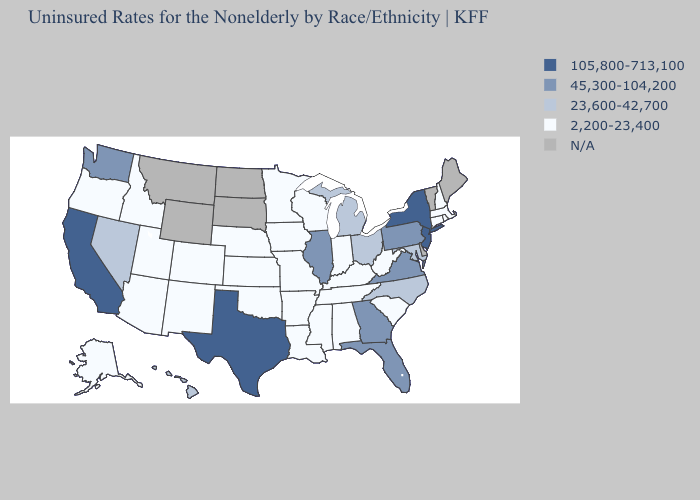What is the value of Wyoming?
Give a very brief answer. N/A. Does Ohio have the lowest value in the MidWest?
Concise answer only. No. Name the states that have a value in the range 23,600-42,700?
Answer briefly. Hawaii, Maryland, Michigan, Nevada, North Carolina, Ohio. Which states have the lowest value in the South?
Short answer required. Alabama, Arkansas, Kentucky, Louisiana, Mississippi, Oklahoma, South Carolina, Tennessee, West Virginia. What is the value of Minnesota?
Answer briefly. 2,200-23,400. Does Maryland have the highest value in the South?
Short answer required. No. What is the value of Vermont?
Concise answer only. N/A. Among the states that border Idaho , does Nevada have the highest value?
Give a very brief answer. No. Name the states that have a value in the range N/A?
Quick response, please. Delaware, Maine, Montana, North Dakota, South Dakota, Vermont, Wyoming. Name the states that have a value in the range 23,600-42,700?
Short answer required. Hawaii, Maryland, Michigan, Nevada, North Carolina, Ohio. What is the value of Maine?
Answer briefly. N/A. Is the legend a continuous bar?
Concise answer only. No. Does the map have missing data?
Answer briefly. Yes. 